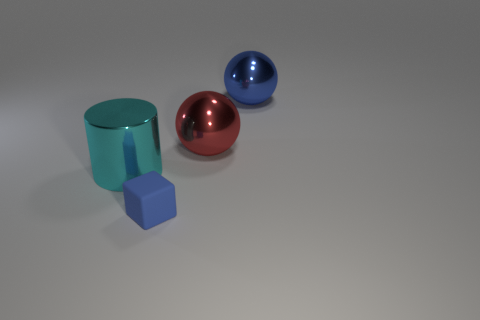Are there any other things of the same color as the big metallic cylinder?
Provide a succinct answer. No. There is a blue thing that is in front of the blue thing behind the cyan shiny object; what shape is it?
Give a very brief answer. Cube. Are there more big cyan objects than tiny brown matte cylinders?
Your answer should be compact. Yes. What number of large metallic things are right of the tiny matte object and left of the blue matte object?
Ensure brevity in your answer.  0. What number of metal spheres are left of the large thing on the right side of the red shiny sphere?
Give a very brief answer. 1. What number of objects are objects that are in front of the cyan metal cylinder or big balls in front of the blue metal sphere?
Give a very brief answer. 2. How many things are either spheres in front of the large blue ball or small yellow matte cubes?
Your response must be concise. 1. What is the shape of the cyan object that is made of the same material as the big blue thing?
Your answer should be compact. Cylinder. How many large cyan metal objects have the same shape as the big blue thing?
Your answer should be very brief. 0. What material is the red ball?
Provide a succinct answer. Metal. 